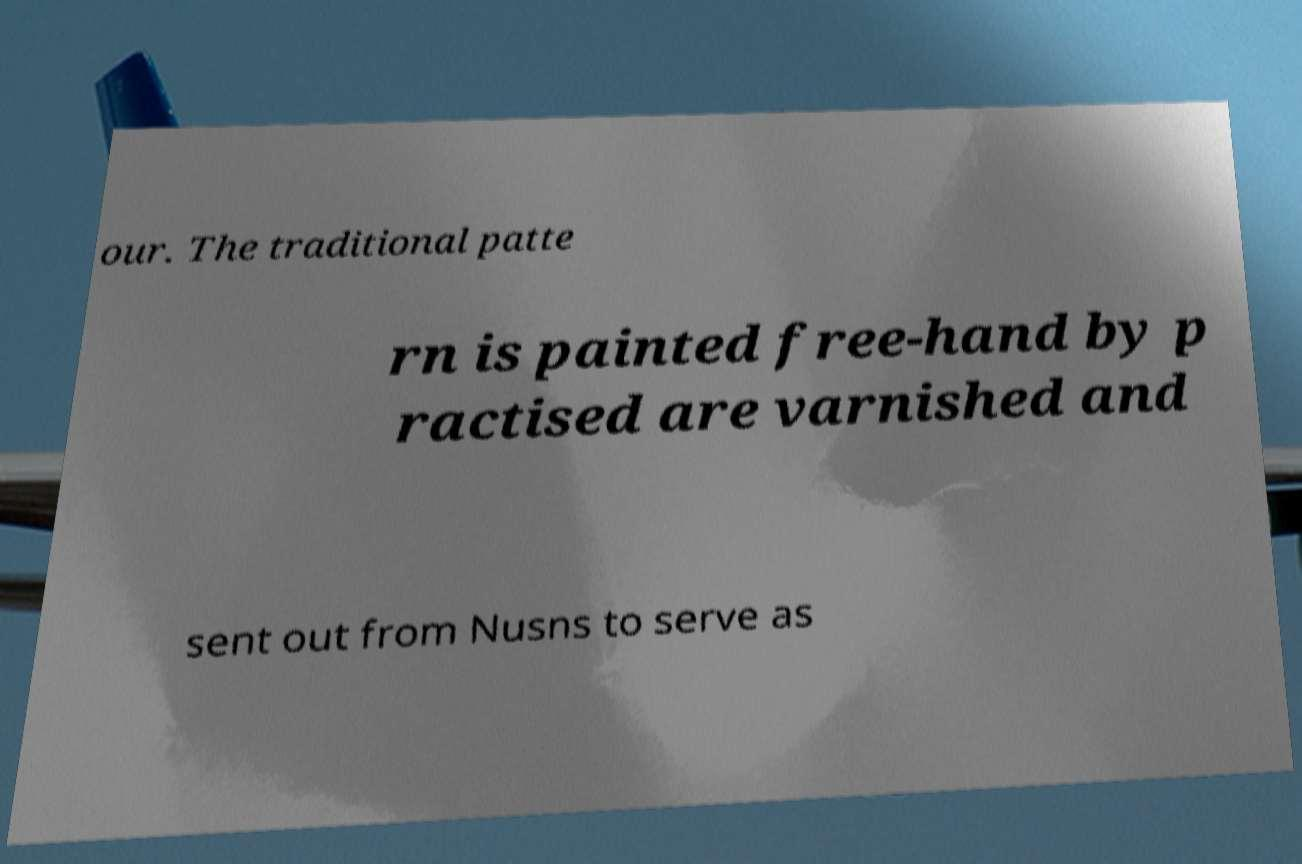Please identify and transcribe the text found in this image. our. The traditional patte rn is painted free-hand by p ractised are varnished and sent out from Nusns to serve as 